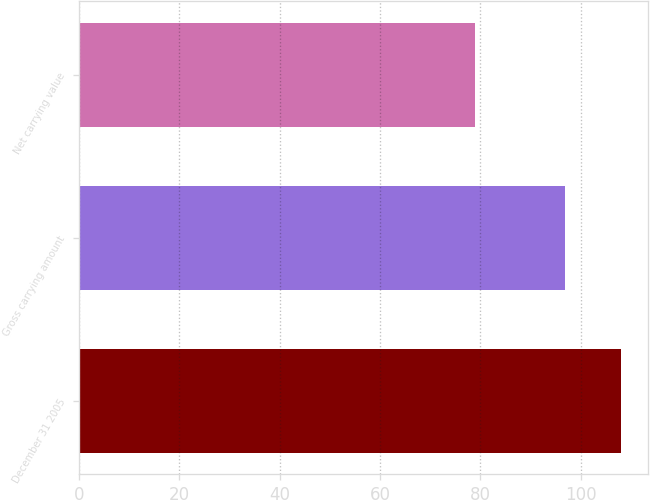<chart> <loc_0><loc_0><loc_500><loc_500><bar_chart><fcel>December 31 2005<fcel>Gross carrying amount<fcel>Net carrying value<nl><fcel>108<fcel>97<fcel>79<nl></chart> 